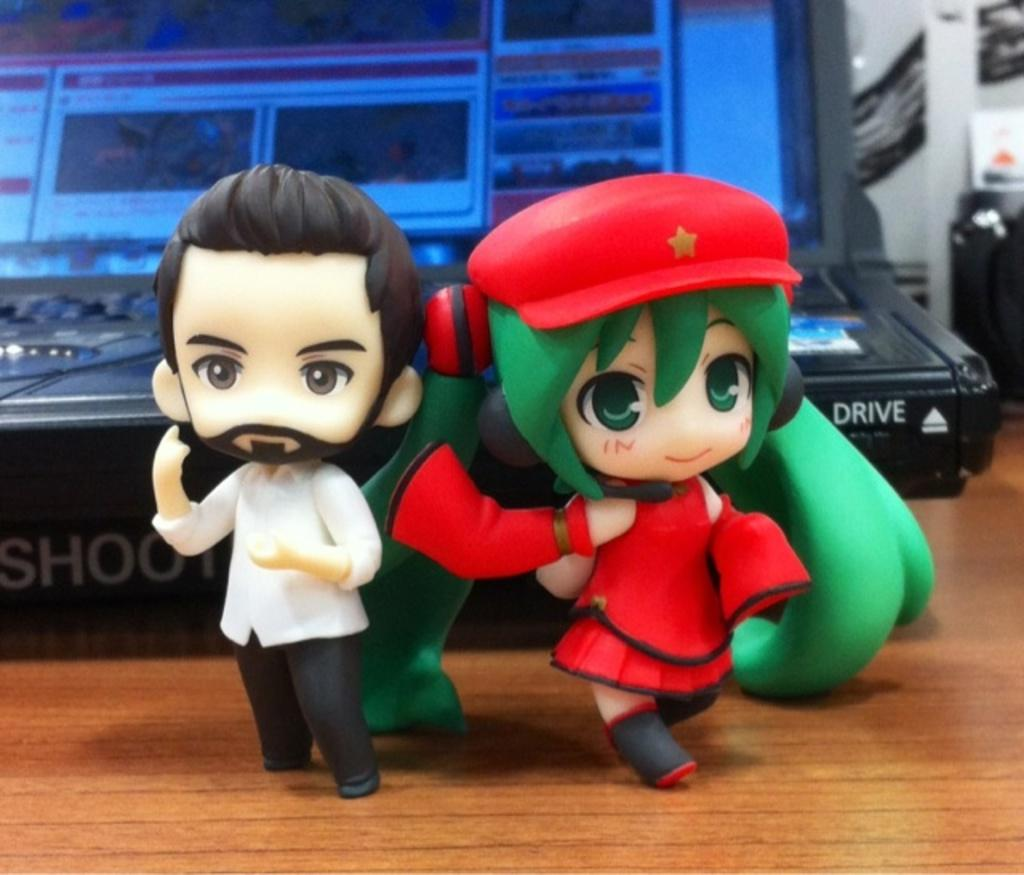What objects are on the wooden surface in the image? There are toys on a wooden surface in the image. Can you describe anything in the background of the image? There is an electronic device in the background of the image. What type of laborer is working in the image? There is no laborer present in the image. What is the cause of the toys being on the wooden surface? The cause of the toys being on the wooden surface is not mentioned in the image or the provided facts. 